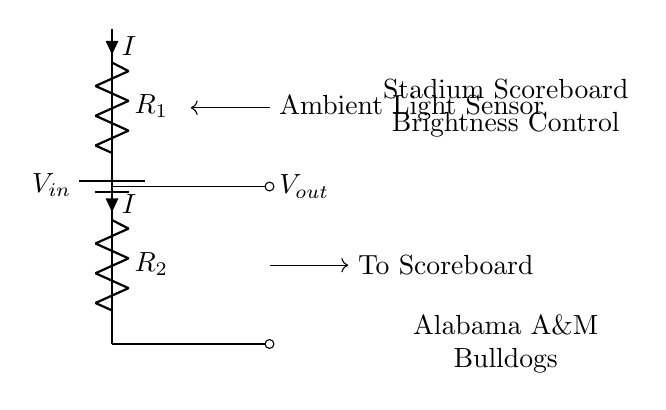What is the input voltage of this circuit? The input voltage is labeled as V_in, indicating the voltage supplied to the circuit.
Answer: V_in What are the two resistors in the circuit? The circuit contains two resistors, R1 and R2, as shown in the diagram. They are connected in series.
Answer: R1, R2 What current flows through the resistors? The current flowing through the resistors is represented by the letter I in the circuit diagram.
Answer: I What is the purpose of this circuit? The purpose of the circuit is to control the brightness of the scoreboard based on the ambient light conditions.
Answer: Brightness control How does the brightness adjust according to ambient light? The output voltage (V_out) is dependent on the division of input voltage across R1 and R2, which varies based on the resistance values affected by ambient light sensed by the sensor.
Answer: By voltage division If R1 is twice the value of R2, what would be the output voltage voltage in terms of Vin? The output voltage is given by the formula V_out = V_in * (R2 / (R1 + R2)). If R1 is twice R2, then V_out = V_in / 3.
Answer: V_in / 3 